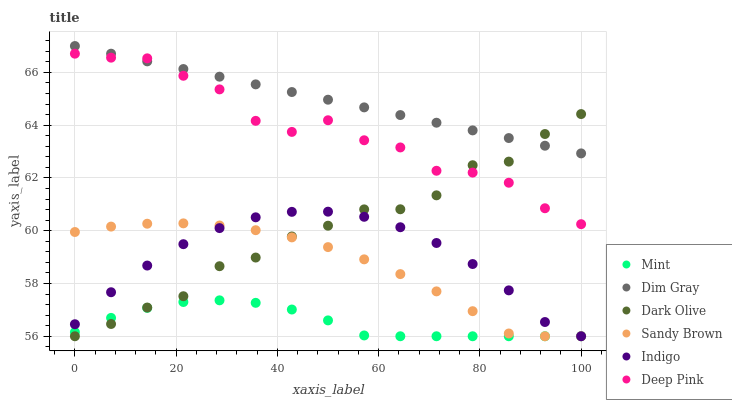Does Mint have the minimum area under the curve?
Answer yes or no. Yes. Does Dim Gray have the maximum area under the curve?
Answer yes or no. Yes. Does Indigo have the minimum area under the curve?
Answer yes or no. No. Does Indigo have the maximum area under the curve?
Answer yes or no. No. Is Dim Gray the smoothest?
Answer yes or no. Yes. Is Deep Pink the roughest?
Answer yes or no. Yes. Is Indigo the smoothest?
Answer yes or no. No. Is Indigo the roughest?
Answer yes or no. No. Does Indigo have the lowest value?
Answer yes or no. Yes. Does Deep Pink have the lowest value?
Answer yes or no. No. Does Dim Gray have the highest value?
Answer yes or no. Yes. Does Indigo have the highest value?
Answer yes or no. No. Is Mint less than Deep Pink?
Answer yes or no. Yes. Is Deep Pink greater than Mint?
Answer yes or no. Yes. Does Dark Olive intersect Sandy Brown?
Answer yes or no. Yes. Is Dark Olive less than Sandy Brown?
Answer yes or no. No. Is Dark Olive greater than Sandy Brown?
Answer yes or no. No. Does Mint intersect Deep Pink?
Answer yes or no. No. 